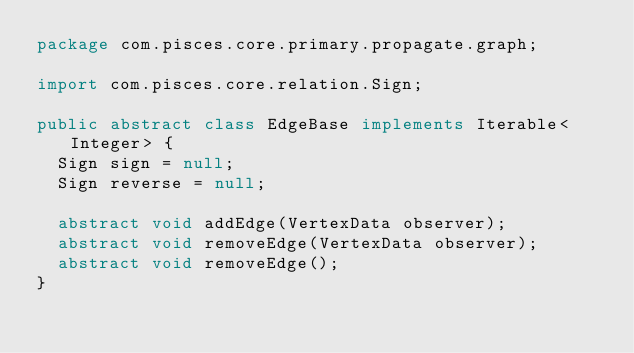<code> <loc_0><loc_0><loc_500><loc_500><_Java_>package com.pisces.core.primary.propagate.graph;

import com.pisces.core.relation.Sign;

public abstract class EdgeBase implements Iterable<Integer> {
	Sign sign = null;
	Sign reverse = null;
	
	abstract void addEdge(VertexData observer);
	abstract void removeEdge(VertexData observer);
	abstract void removeEdge();
}
</code> 